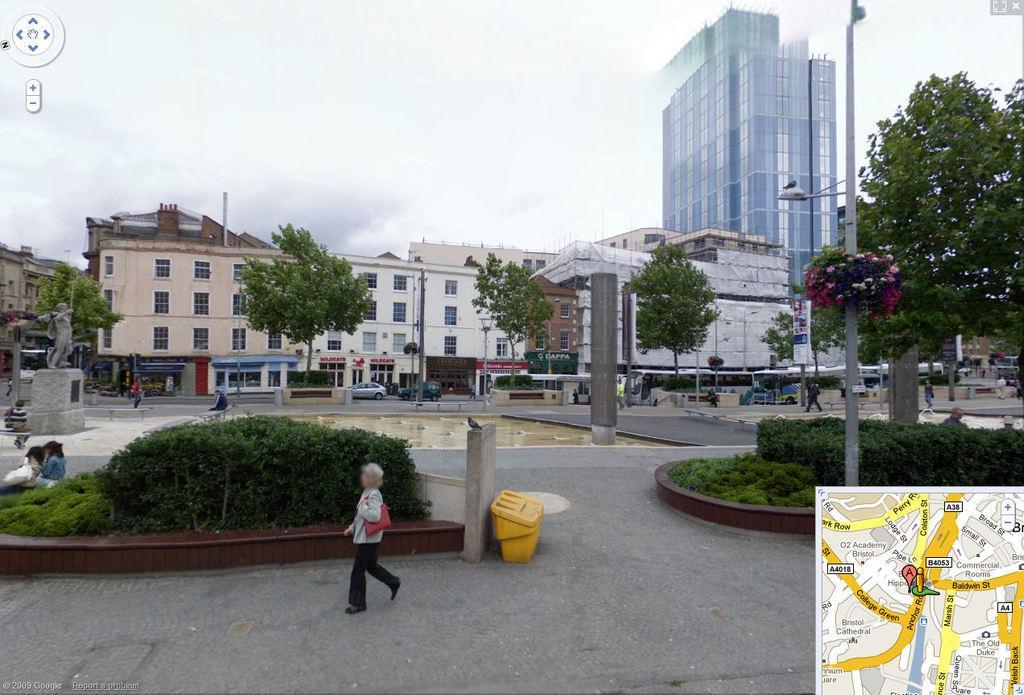Could you give a brief overview of what you see in this image? In this picture we can observe a person walking. On the right side we can observe a map. There is yellow color trash bin. We can observe some plants here. There is a pole on the right side. In the background there are trees, buildings and a sky with some clouds. 